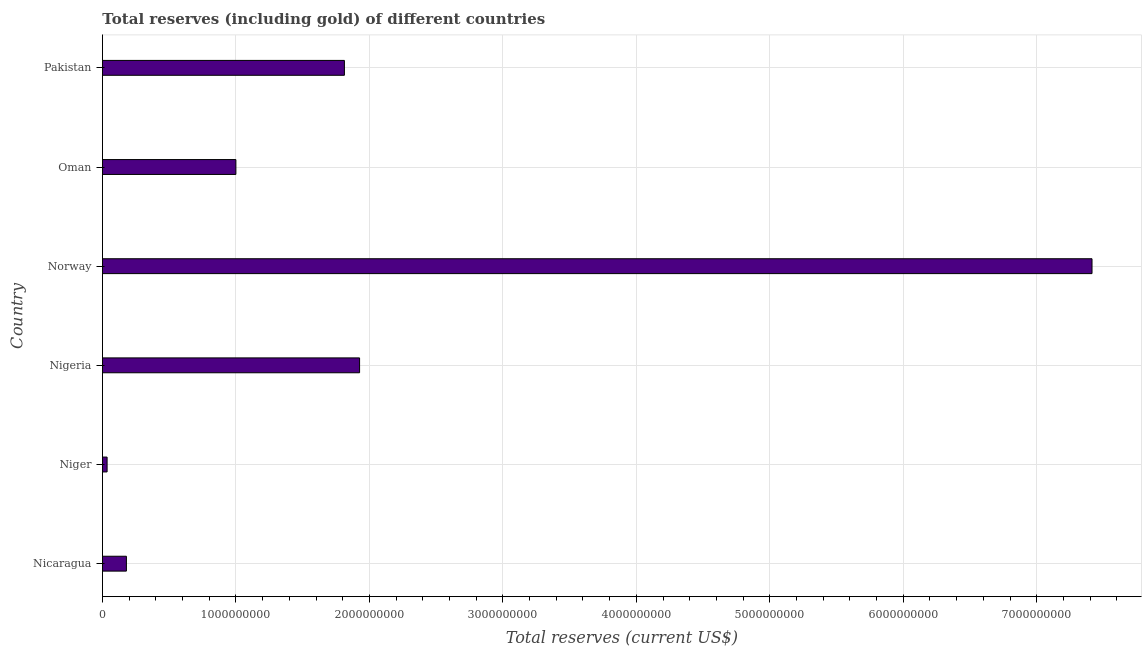What is the title of the graph?
Ensure brevity in your answer.  Total reserves (including gold) of different countries. What is the label or title of the X-axis?
Provide a short and direct response. Total reserves (current US$). What is the label or title of the Y-axis?
Offer a very short reply. Country. What is the total reserves (including gold) in Oman?
Keep it short and to the point. 1.00e+09. Across all countries, what is the maximum total reserves (including gold)?
Offer a terse response. 7.41e+09. Across all countries, what is the minimum total reserves (including gold)?
Offer a very short reply. 3.47e+07. In which country was the total reserves (including gold) maximum?
Make the answer very short. Norway. In which country was the total reserves (including gold) minimum?
Ensure brevity in your answer.  Niger. What is the sum of the total reserves (including gold)?
Offer a very short reply. 1.24e+1. What is the difference between the total reserves (including gold) in Niger and Pakistan?
Your answer should be compact. -1.78e+09. What is the average total reserves (including gold) per country?
Give a very brief answer. 2.06e+09. What is the median total reserves (including gold)?
Give a very brief answer. 1.41e+09. In how many countries, is the total reserves (including gold) greater than 2800000000 US$?
Offer a very short reply. 1. What is the ratio of the total reserves (including gold) in Nicaragua to that in Oman?
Ensure brevity in your answer.  0.18. What is the difference between the highest and the second highest total reserves (including gold)?
Your answer should be very brief. 5.49e+09. What is the difference between the highest and the lowest total reserves (including gold)?
Your answer should be compact. 7.38e+09. In how many countries, is the total reserves (including gold) greater than the average total reserves (including gold) taken over all countries?
Make the answer very short. 1. How many countries are there in the graph?
Provide a short and direct response. 6. What is the difference between two consecutive major ticks on the X-axis?
Your answer should be very brief. 1.00e+09. What is the Total reserves (current US$) of Nicaragua?
Ensure brevity in your answer.  1.79e+08. What is the Total reserves (current US$) in Niger?
Your answer should be very brief. 3.47e+07. What is the Total reserves (current US$) of Nigeria?
Keep it short and to the point. 1.93e+09. What is the Total reserves (current US$) in Norway?
Make the answer very short. 7.41e+09. What is the Total reserves (current US$) of Oman?
Ensure brevity in your answer.  1.00e+09. What is the Total reserves (current US$) of Pakistan?
Your response must be concise. 1.81e+09. What is the difference between the Total reserves (current US$) in Nicaragua and Niger?
Your answer should be compact. 1.45e+08. What is the difference between the Total reserves (current US$) in Nicaragua and Nigeria?
Keep it short and to the point. -1.75e+09. What is the difference between the Total reserves (current US$) in Nicaragua and Norway?
Your answer should be compact. -7.24e+09. What is the difference between the Total reserves (current US$) in Nicaragua and Oman?
Offer a terse response. -8.20e+08. What is the difference between the Total reserves (current US$) in Nicaragua and Pakistan?
Give a very brief answer. -1.63e+09. What is the difference between the Total reserves (current US$) in Niger and Nigeria?
Give a very brief answer. -1.89e+09. What is the difference between the Total reserves (current US$) in Niger and Norway?
Keep it short and to the point. -7.38e+09. What is the difference between the Total reserves (current US$) in Niger and Oman?
Give a very brief answer. -9.65e+08. What is the difference between the Total reserves (current US$) in Niger and Pakistan?
Make the answer very short. -1.78e+09. What is the difference between the Total reserves (current US$) in Nigeria and Norway?
Your response must be concise. -5.49e+09. What is the difference between the Total reserves (current US$) in Nigeria and Oman?
Make the answer very short. 9.27e+08. What is the difference between the Total reserves (current US$) in Nigeria and Pakistan?
Ensure brevity in your answer.  1.14e+08. What is the difference between the Total reserves (current US$) in Norway and Oman?
Provide a succinct answer. 6.41e+09. What is the difference between the Total reserves (current US$) in Norway and Pakistan?
Provide a short and direct response. 5.60e+09. What is the difference between the Total reserves (current US$) in Oman and Pakistan?
Offer a terse response. -8.13e+08. What is the ratio of the Total reserves (current US$) in Nicaragua to that in Niger?
Make the answer very short. 5.17. What is the ratio of the Total reserves (current US$) in Nicaragua to that in Nigeria?
Keep it short and to the point. 0.09. What is the ratio of the Total reserves (current US$) in Nicaragua to that in Norway?
Provide a short and direct response. 0.02. What is the ratio of the Total reserves (current US$) in Nicaragua to that in Oman?
Keep it short and to the point. 0.18. What is the ratio of the Total reserves (current US$) in Nicaragua to that in Pakistan?
Ensure brevity in your answer.  0.1. What is the ratio of the Total reserves (current US$) in Niger to that in Nigeria?
Ensure brevity in your answer.  0.02. What is the ratio of the Total reserves (current US$) in Niger to that in Norway?
Your answer should be very brief. 0.01. What is the ratio of the Total reserves (current US$) in Niger to that in Oman?
Offer a terse response. 0.04. What is the ratio of the Total reserves (current US$) in Niger to that in Pakistan?
Your answer should be very brief. 0.02. What is the ratio of the Total reserves (current US$) in Nigeria to that in Norway?
Keep it short and to the point. 0.26. What is the ratio of the Total reserves (current US$) in Nigeria to that in Oman?
Make the answer very short. 1.93. What is the ratio of the Total reserves (current US$) in Nigeria to that in Pakistan?
Your answer should be very brief. 1.06. What is the ratio of the Total reserves (current US$) in Norway to that in Oman?
Offer a terse response. 7.42. What is the ratio of the Total reserves (current US$) in Norway to that in Pakistan?
Provide a succinct answer. 4.09. What is the ratio of the Total reserves (current US$) in Oman to that in Pakistan?
Offer a terse response. 0.55. 